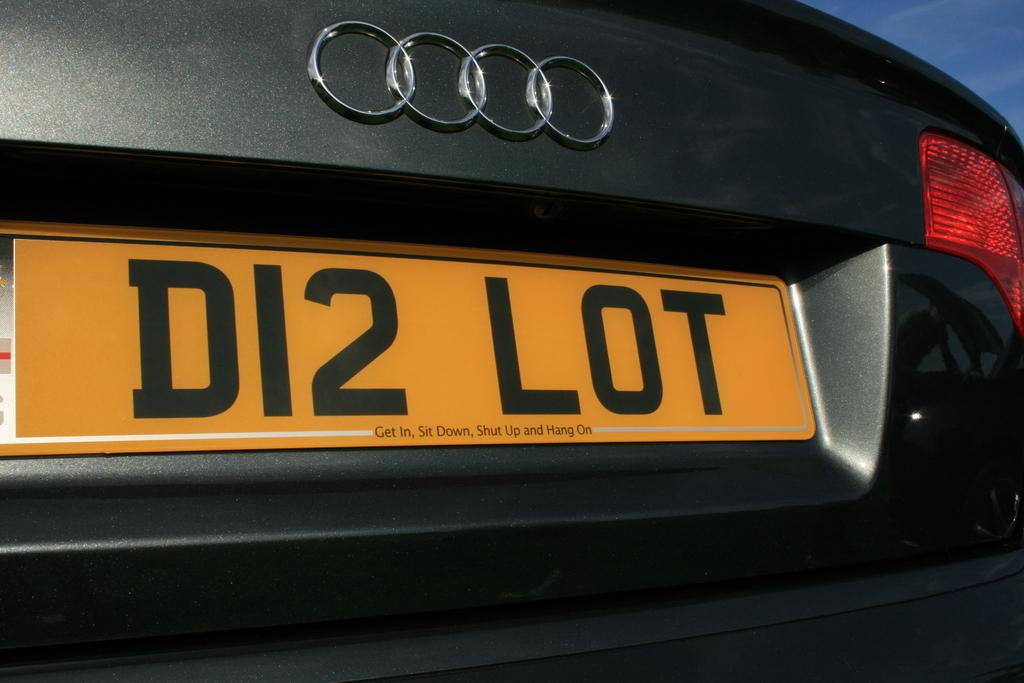<image>
Provide a brief description of the given image. the word lot is on the license plate of the car 